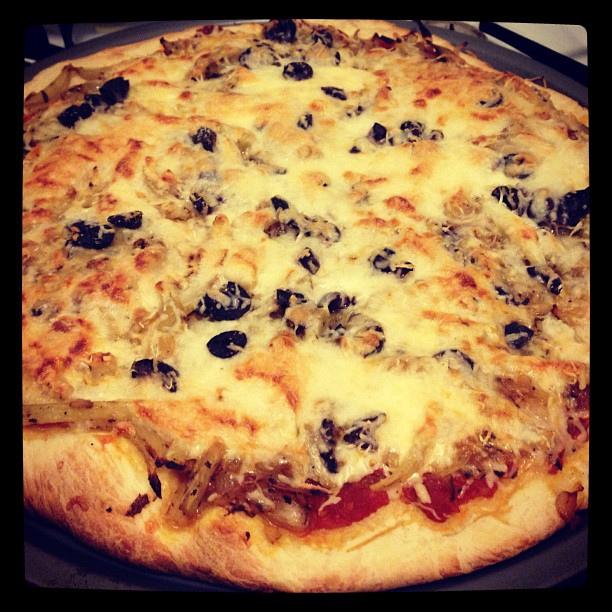What is red on the pizza?
Answer briefly. Sauce. What country invented pizza?
Be succinct. Italy. Is the pizza inside a box?
Quick response, please. No. Do you think this is a homemade pizza?
Short answer required. Yes. Does the top of this dish resemble scrambled eggs?
Write a very short answer. No. What are the black toppings?
Write a very short answer. Olives. Is the crust thin?
Short answer required. No. 